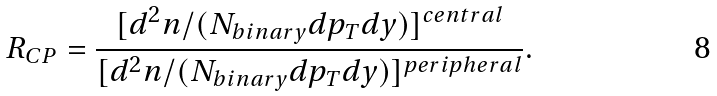Convert formula to latex. <formula><loc_0><loc_0><loc_500><loc_500>R _ { C P } = \frac { [ d ^ { 2 } n / ( N _ { b i n a r y } d p _ { T } d y ) ] ^ { c e n t r a l } } { [ d ^ { 2 } n / ( N _ { b i n a r y } d p _ { T } d y ) ] ^ { p e r i p h e r a l } } .</formula> 